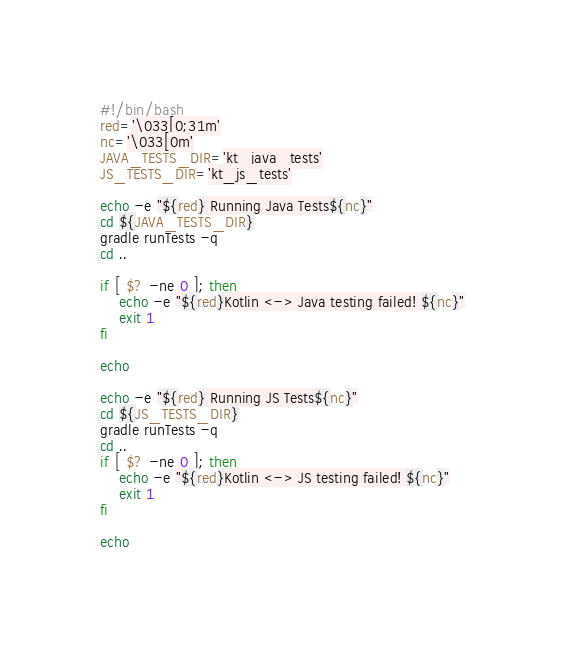Convert code to text. <code><loc_0><loc_0><loc_500><loc_500><_Bash_>#!/bin/bash
red='\033[0;31m'
nc='\033[0m'
JAVA_TESTS_DIR='kt_java_tests'
JS_TESTS_DIR='kt_js_tests'

echo -e "${red} Running Java Tests${nc}"
cd ${JAVA_TESTS_DIR}
gradle runTests -q
cd ..

if [ $? -ne 0 ]; then
	echo -e "${red}Kotlin <-> Java testing failed! ${nc}"
	exit 1
fi

echo

echo -e "${red} Running JS Tests${nc}"
cd ${JS_TESTS_DIR}
gradle runTests -q
cd ..
if [ $? -ne 0 ]; then
	echo -e "${red}Kotlin <-> JS testing failed! ${nc}"
	exit 1
fi

echo
</code> 